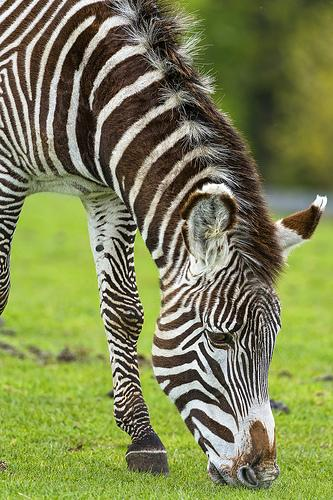Characterize the chief subject in the image and their ongoing activity. The striking brown and white striped zebra is captured while enjoying a grass meal in a lush field. Narrate what the main subject in the image is doing and some of its characteristics. The zebra, which is brown and white striped, is munching on grass while standing on a green field. Depict the appearance of the chief object in the picture and its ongoing activity. A brown and white zebra with contrasting stripes is calmly grazing on the grass amongst short green foliage. Provide a brief description of the primary object in the scene and its action. A brown and white zebra is grazing on short green grass in a grassy field. Outline the most striking features of the main subject in the image and what it is engaged in. A striped zebra with perked forward ears and a short mane is eating grass in a field. Portray the main focus of the image and the action that is occurring. The zebra, marked by its unusual brown and white stripes, is busily consuming grass in a verdant setting. Illustrate the predominant features of the main subject and its present action. A uniquely brown and white striped zebra is focused on grazing in the midst of the short green grass. Explain the most noticeable characteristics of the main subject and what they are involved in. The zebra, with distinct brown and white stripes, is busily foraging on the short green grass. Elucidate the essential attributes of the principal figure in the image and their current behavior. The prominently striped brown and white zebra is visibly engaged in the act of consuming grass in a verdant field. Describe the main object in the photograph and the action taking place. The image features a zebra with white and brown stripes, intently eating grass in a green grass-covered area. 